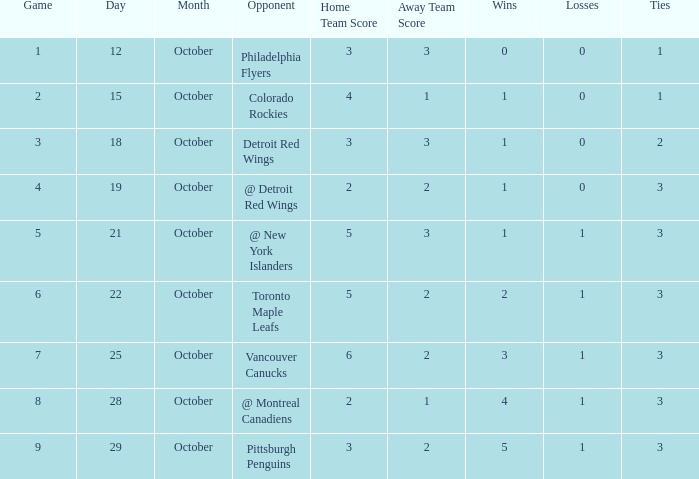Name the most october for game less than 1 None. 